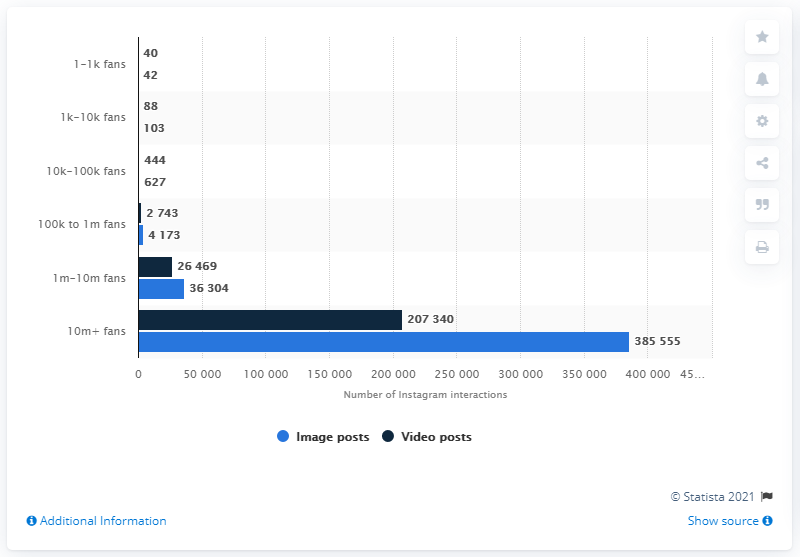Mention a couple of crucial points in this snapshot. The average number of user interactions per post on Instagram is approximately 627. 